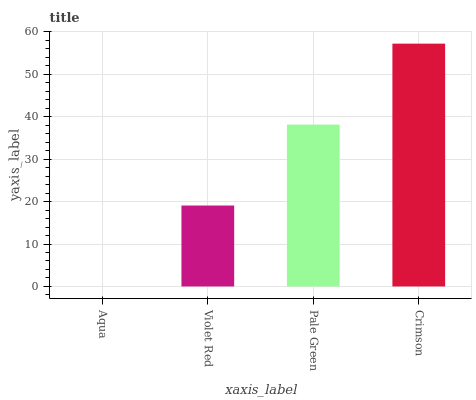Is Aqua the minimum?
Answer yes or no. Yes. Is Crimson the maximum?
Answer yes or no. Yes. Is Violet Red the minimum?
Answer yes or no. No. Is Violet Red the maximum?
Answer yes or no. No. Is Violet Red greater than Aqua?
Answer yes or no. Yes. Is Aqua less than Violet Red?
Answer yes or no. Yes. Is Aqua greater than Violet Red?
Answer yes or no. No. Is Violet Red less than Aqua?
Answer yes or no. No. Is Pale Green the high median?
Answer yes or no. Yes. Is Violet Red the low median?
Answer yes or no. Yes. Is Violet Red the high median?
Answer yes or no. No. Is Pale Green the low median?
Answer yes or no. No. 